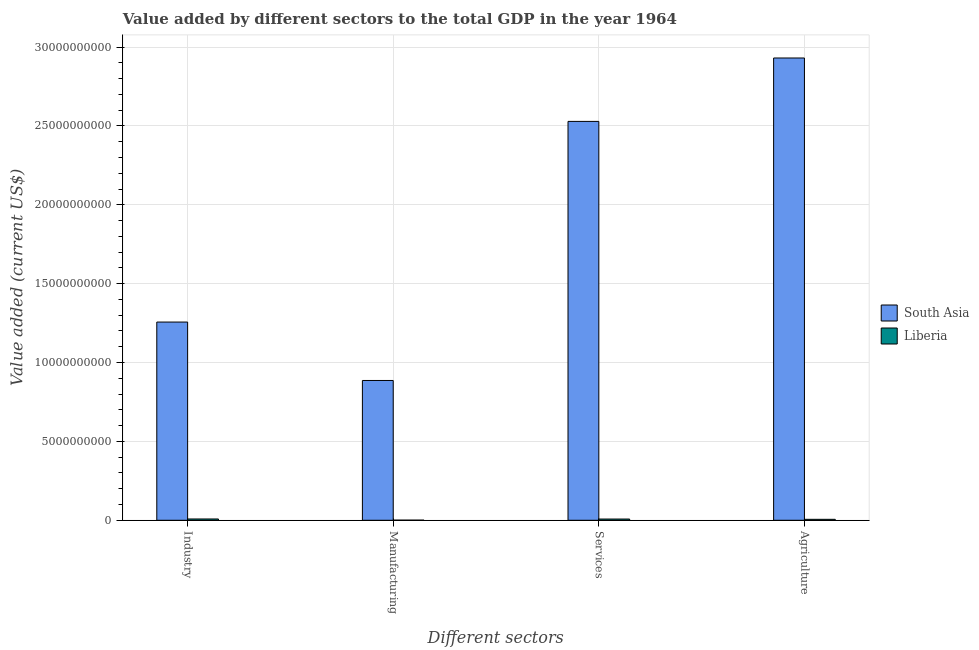How many groups of bars are there?
Provide a short and direct response. 4. Are the number of bars per tick equal to the number of legend labels?
Provide a succinct answer. Yes. How many bars are there on the 3rd tick from the left?
Offer a terse response. 2. What is the label of the 3rd group of bars from the left?
Keep it short and to the point. Services. What is the value added by agricultural sector in Liberia?
Your answer should be compact. 5.97e+07. Across all countries, what is the maximum value added by industrial sector?
Your response must be concise. 1.26e+1. Across all countries, what is the minimum value added by services sector?
Offer a very short reply. 7.74e+07. In which country was the value added by manufacturing sector minimum?
Offer a terse response. Liberia. What is the total value added by manufacturing sector in the graph?
Provide a short and direct response. 8.87e+09. What is the difference between the value added by services sector in Liberia and that in South Asia?
Keep it short and to the point. -2.52e+1. What is the difference between the value added by agricultural sector in Liberia and the value added by services sector in South Asia?
Your answer should be compact. -2.52e+1. What is the average value added by industrial sector per country?
Offer a very short reply. 6.32e+09. What is the difference between the value added by manufacturing sector and value added by services sector in Liberia?
Provide a short and direct response. -7.11e+07. In how many countries, is the value added by services sector greater than 18000000000 US$?
Offer a terse response. 1. What is the ratio of the value added by industrial sector in Liberia to that in South Asia?
Give a very brief answer. 0.01. Is the value added by agricultural sector in Liberia less than that in South Asia?
Ensure brevity in your answer.  Yes. What is the difference between the highest and the second highest value added by services sector?
Ensure brevity in your answer.  2.52e+1. What is the difference between the highest and the lowest value added by industrial sector?
Offer a terse response. 1.25e+1. What does the 2nd bar from the left in Agriculture represents?
Keep it short and to the point. Liberia. What does the 1st bar from the right in Manufacturing represents?
Offer a terse response. Liberia. Are all the bars in the graph horizontal?
Ensure brevity in your answer.  No. How many countries are there in the graph?
Make the answer very short. 2. What is the difference between two consecutive major ticks on the Y-axis?
Give a very brief answer. 5.00e+09. Are the values on the major ticks of Y-axis written in scientific E-notation?
Give a very brief answer. No. Does the graph contain grids?
Make the answer very short. Yes. How are the legend labels stacked?
Your answer should be very brief. Vertical. What is the title of the graph?
Provide a short and direct response. Value added by different sectors to the total GDP in the year 1964. What is the label or title of the X-axis?
Provide a succinct answer. Different sectors. What is the label or title of the Y-axis?
Keep it short and to the point. Value added (current US$). What is the Value added (current US$) of South Asia in Industry?
Your answer should be very brief. 1.26e+1. What is the Value added (current US$) in Liberia in Industry?
Your answer should be very brief. 8.19e+07. What is the Value added (current US$) of South Asia in Manufacturing?
Make the answer very short. 8.86e+09. What is the Value added (current US$) in Liberia in Manufacturing?
Provide a succinct answer. 6.23e+06. What is the Value added (current US$) of South Asia in Services?
Make the answer very short. 2.53e+1. What is the Value added (current US$) of Liberia in Services?
Provide a short and direct response. 7.74e+07. What is the Value added (current US$) in South Asia in Agriculture?
Provide a succinct answer. 2.93e+1. What is the Value added (current US$) in Liberia in Agriculture?
Make the answer very short. 5.97e+07. Across all Different sectors, what is the maximum Value added (current US$) of South Asia?
Your answer should be compact. 2.93e+1. Across all Different sectors, what is the maximum Value added (current US$) in Liberia?
Ensure brevity in your answer.  8.19e+07. Across all Different sectors, what is the minimum Value added (current US$) in South Asia?
Ensure brevity in your answer.  8.86e+09. Across all Different sectors, what is the minimum Value added (current US$) of Liberia?
Your response must be concise. 6.23e+06. What is the total Value added (current US$) in South Asia in the graph?
Offer a terse response. 7.60e+1. What is the total Value added (current US$) in Liberia in the graph?
Your answer should be very brief. 2.25e+08. What is the difference between the Value added (current US$) in South Asia in Industry and that in Manufacturing?
Offer a terse response. 3.70e+09. What is the difference between the Value added (current US$) of Liberia in Industry and that in Manufacturing?
Your answer should be compact. 7.57e+07. What is the difference between the Value added (current US$) in South Asia in Industry and that in Services?
Give a very brief answer. -1.27e+1. What is the difference between the Value added (current US$) in Liberia in Industry and that in Services?
Ensure brevity in your answer.  4.53e+06. What is the difference between the Value added (current US$) of South Asia in Industry and that in Agriculture?
Ensure brevity in your answer.  -1.67e+1. What is the difference between the Value added (current US$) in Liberia in Industry and that in Agriculture?
Your answer should be very brief. 2.22e+07. What is the difference between the Value added (current US$) in South Asia in Manufacturing and that in Services?
Your answer should be compact. -1.64e+1. What is the difference between the Value added (current US$) of Liberia in Manufacturing and that in Services?
Keep it short and to the point. -7.11e+07. What is the difference between the Value added (current US$) in South Asia in Manufacturing and that in Agriculture?
Your response must be concise. -2.04e+1. What is the difference between the Value added (current US$) in Liberia in Manufacturing and that in Agriculture?
Offer a terse response. -5.35e+07. What is the difference between the Value added (current US$) of South Asia in Services and that in Agriculture?
Your answer should be compact. -4.02e+09. What is the difference between the Value added (current US$) in Liberia in Services and that in Agriculture?
Provide a succinct answer. 1.77e+07. What is the difference between the Value added (current US$) of South Asia in Industry and the Value added (current US$) of Liberia in Manufacturing?
Give a very brief answer. 1.26e+1. What is the difference between the Value added (current US$) of South Asia in Industry and the Value added (current US$) of Liberia in Services?
Offer a very short reply. 1.25e+1. What is the difference between the Value added (current US$) of South Asia in Industry and the Value added (current US$) of Liberia in Agriculture?
Provide a short and direct response. 1.25e+1. What is the difference between the Value added (current US$) of South Asia in Manufacturing and the Value added (current US$) of Liberia in Services?
Keep it short and to the point. 8.79e+09. What is the difference between the Value added (current US$) in South Asia in Manufacturing and the Value added (current US$) in Liberia in Agriculture?
Give a very brief answer. 8.80e+09. What is the difference between the Value added (current US$) in South Asia in Services and the Value added (current US$) in Liberia in Agriculture?
Offer a terse response. 2.52e+1. What is the average Value added (current US$) in South Asia per Different sectors?
Provide a succinct answer. 1.90e+1. What is the average Value added (current US$) of Liberia per Different sectors?
Offer a very short reply. 5.63e+07. What is the difference between the Value added (current US$) of South Asia and Value added (current US$) of Liberia in Industry?
Your answer should be very brief. 1.25e+1. What is the difference between the Value added (current US$) of South Asia and Value added (current US$) of Liberia in Manufacturing?
Offer a very short reply. 8.86e+09. What is the difference between the Value added (current US$) in South Asia and Value added (current US$) in Liberia in Services?
Offer a terse response. 2.52e+1. What is the difference between the Value added (current US$) of South Asia and Value added (current US$) of Liberia in Agriculture?
Your response must be concise. 2.92e+1. What is the ratio of the Value added (current US$) in South Asia in Industry to that in Manufacturing?
Offer a terse response. 1.42. What is the ratio of the Value added (current US$) of Liberia in Industry to that in Manufacturing?
Offer a very short reply. 13.14. What is the ratio of the Value added (current US$) in South Asia in Industry to that in Services?
Your answer should be very brief. 0.5. What is the ratio of the Value added (current US$) of Liberia in Industry to that in Services?
Provide a short and direct response. 1.06. What is the ratio of the Value added (current US$) in South Asia in Industry to that in Agriculture?
Ensure brevity in your answer.  0.43. What is the ratio of the Value added (current US$) in Liberia in Industry to that in Agriculture?
Offer a terse response. 1.37. What is the ratio of the Value added (current US$) of South Asia in Manufacturing to that in Services?
Your answer should be very brief. 0.35. What is the ratio of the Value added (current US$) in Liberia in Manufacturing to that in Services?
Your response must be concise. 0.08. What is the ratio of the Value added (current US$) of South Asia in Manufacturing to that in Agriculture?
Your answer should be very brief. 0.3. What is the ratio of the Value added (current US$) in Liberia in Manufacturing to that in Agriculture?
Offer a terse response. 0.1. What is the ratio of the Value added (current US$) of South Asia in Services to that in Agriculture?
Provide a succinct answer. 0.86. What is the ratio of the Value added (current US$) in Liberia in Services to that in Agriculture?
Your response must be concise. 1.3. What is the difference between the highest and the second highest Value added (current US$) of South Asia?
Ensure brevity in your answer.  4.02e+09. What is the difference between the highest and the second highest Value added (current US$) in Liberia?
Provide a succinct answer. 4.53e+06. What is the difference between the highest and the lowest Value added (current US$) in South Asia?
Provide a succinct answer. 2.04e+1. What is the difference between the highest and the lowest Value added (current US$) in Liberia?
Ensure brevity in your answer.  7.57e+07. 